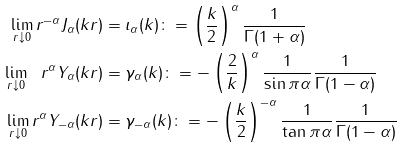<formula> <loc_0><loc_0><loc_500><loc_500>\lim _ { r \downarrow 0 } r ^ { - \alpha } J _ { \alpha } ( k r ) & = \iota _ { \alpha } ( k ) \colon = \left ( \frac { k } { 2 } \right ) ^ { \alpha } \frac { 1 } { \Gamma ( 1 + \alpha ) } \\ \lim _ { r \downarrow 0 } \ \ r ^ { \alpha } Y _ { \alpha } ( k r ) & = \gamma _ { \alpha } ( k ) \colon = - \left ( \frac { 2 } { k } \right ) ^ { \alpha } \frac { 1 } { \sin \pi \alpha } \frac { 1 } { \Gamma ( 1 - \alpha ) } \\ \lim _ { r \downarrow 0 } r ^ { \alpha } Y _ { - \alpha } ( k r ) & = \gamma _ { - \alpha } ( k ) \colon = - \left ( \frac { k } { 2 } \right ) ^ { - \alpha } \frac { 1 } { \tan \pi \alpha } \frac { 1 } { \Gamma ( 1 - \alpha ) }</formula> 